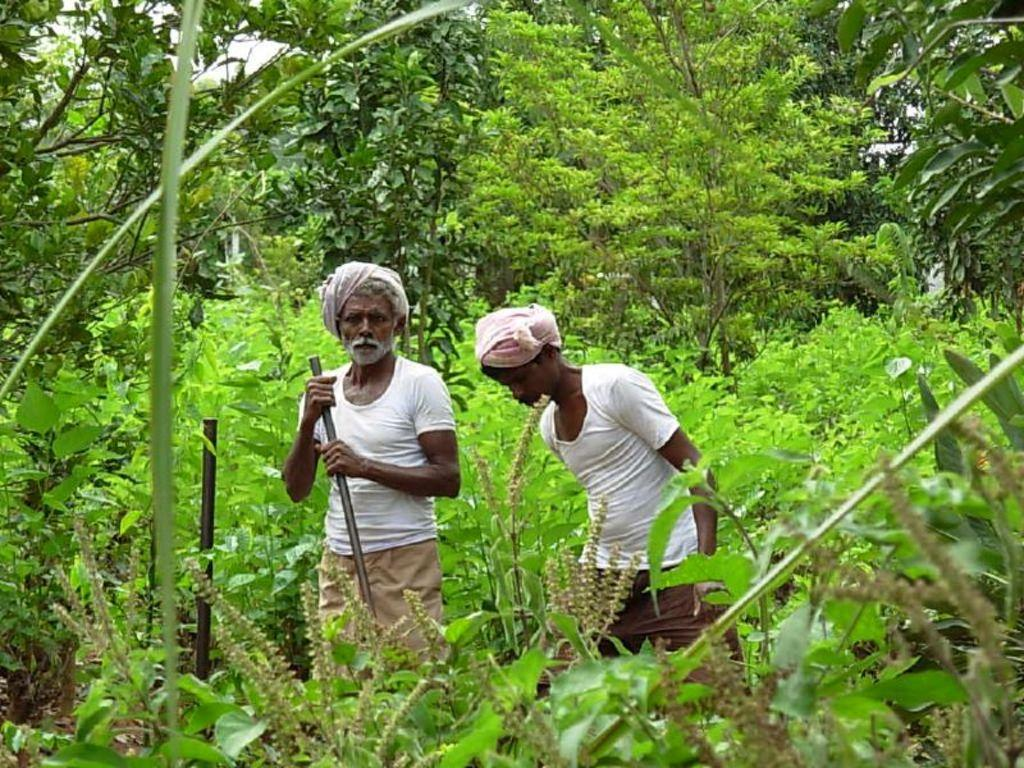What is happening in the center of the image? There are persons standing in the center of the image. What can be seen in the background of the image? There are trees in the background of the image. Are there any plants visible in the image? Yes, there are plants in the image. What type of waves can be seen crashing on the shore in the image? There are no waves or shore present in the image; it features persons standing and trees in the background. 